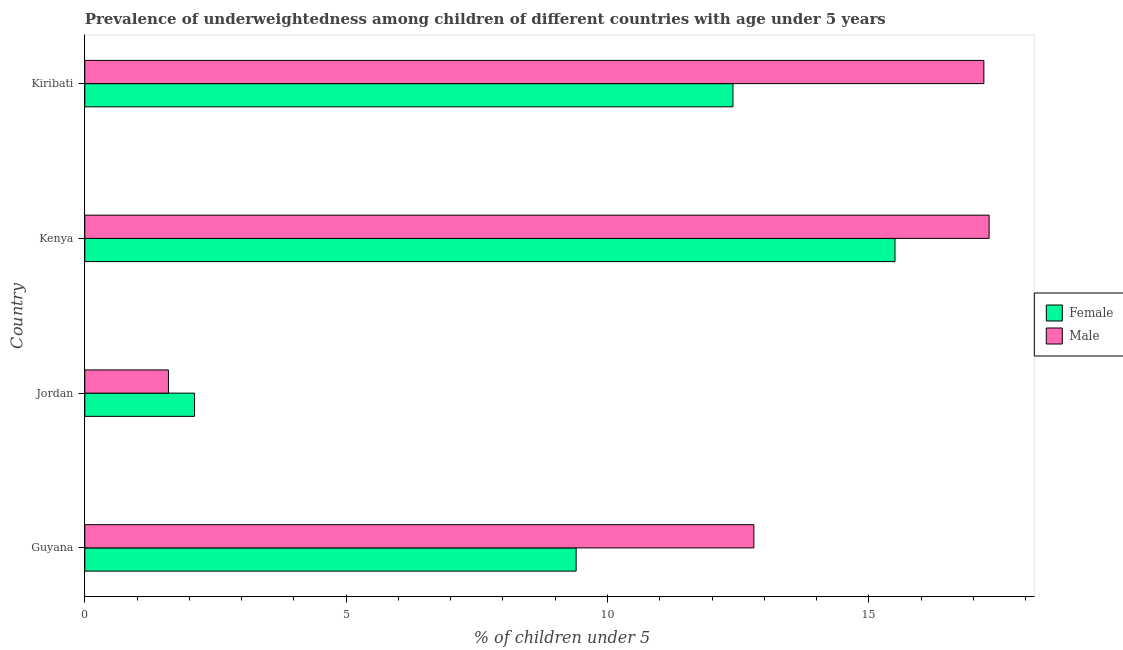How many different coloured bars are there?
Offer a terse response. 2. How many groups of bars are there?
Provide a succinct answer. 4. Are the number of bars per tick equal to the number of legend labels?
Your answer should be very brief. Yes. Are the number of bars on each tick of the Y-axis equal?
Provide a succinct answer. Yes. How many bars are there on the 4th tick from the top?
Your answer should be very brief. 2. What is the label of the 4th group of bars from the top?
Provide a short and direct response. Guyana. In how many cases, is the number of bars for a given country not equal to the number of legend labels?
Keep it short and to the point. 0. What is the percentage of underweighted female children in Guyana?
Give a very brief answer. 9.4. Across all countries, what is the maximum percentage of underweighted male children?
Offer a very short reply. 17.3. Across all countries, what is the minimum percentage of underweighted female children?
Ensure brevity in your answer.  2.1. In which country was the percentage of underweighted female children maximum?
Offer a very short reply. Kenya. In which country was the percentage of underweighted female children minimum?
Give a very brief answer. Jordan. What is the total percentage of underweighted male children in the graph?
Your answer should be compact. 48.9. What is the difference between the percentage of underweighted male children in Kenya and the percentage of underweighted female children in Kiribati?
Ensure brevity in your answer.  4.9. What is the average percentage of underweighted male children per country?
Provide a succinct answer. 12.22. In how many countries, is the percentage of underweighted female children greater than 4 %?
Ensure brevity in your answer.  3. What is the ratio of the percentage of underweighted male children in Guyana to that in Kiribati?
Keep it short and to the point. 0.74. Is the difference between the percentage of underweighted male children in Jordan and Kenya greater than the difference between the percentage of underweighted female children in Jordan and Kenya?
Your answer should be very brief. No. What is the difference between the highest and the lowest percentage of underweighted male children?
Provide a short and direct response. 15.7. In how many countries, is the percentage of underweighted male children greater than the average percentage of underweighted male children taken over all countries?
Offer a terse response. 3. What does the 1st bar from the top in Jordan represents?
Your response must be concise. Male. How many bars are there?
Provide a succinct answer. 8. Are the values on the major ticks of X-axis written in scientific E-notation?
Your answer should be compact. No. Does the graph contain any zero values?
Your answer should be compact. No. What is the title of the graph?
Offer a very short reply. Prevalence of underweightedness among children of different countries with age under 5 years. What is the label or title of the X-axis?
Keep it short and to the point.  % of children under 5. What is the label or title of the Y-axis?
Provide a succinct answer. Country. What is the  % of children under 5 of Female in Guyana?
Ensure brevity in your answer.  9.4. What is the  % of children under 5 in Male in Guyana?
Your answer should be compact. 12.8. What is the  % of children under 5 in Female in Jordan?
Your answer should be very brief. 2.1. What is the  % of children under 5 in Male in Jordan?
Provide a short and direct response. 1.6. What is the  % of children under 5 of Female in Kenya?
Give a very brief answer. 15.5. What is the  % of children under 5 of Male in Kenya?
Your answer should be compact. 17.3. What is the  % of children under 5 in Female in Kiribati?
Provide a succinct answer. 12.4. What is the  % of children under 5 in Male in Kiribati?
Offer a terse response. 17.2. Across all countries, what is the maximum  % of children under 5 of Male?
Your response must be concise. 17.3. Across all countries, what is the minimum  % of children under 5 of Female?
Your response must be concise. 2.1. Across all countries, what is the minimum  % of children under 5 in Male?
Offer a terse response. 1.6. What is the total  % of children under 5 in Female in the graph?
Your response must be concise. 39.4. What is the total  % of children under 5 of Male in the graph?
Offer a terse response. 48.9. What is the difference between the  % of children under 5 of Female in Guyana and that in Jordan?
Your answer should be compact. 7.3. What is the difference between the  % of children under 5 in Male in Guyana and that in Jordan?
Your response must be concise. 11.2. What is the difference between the  % of children under 5 of Male in Guyana and that in Kenya?
Your response must be concise. -4.5. What is the difference between the  % of children under 5 in Female in Guyana and that in Kiribati?
Your answer should be very brief. -3. What is the difference between the  % of children under 5 of Female in Jordan and that in Kenya?
Your answer should be very brief. -13.4. What is the difference between the  % of children under 5 in Male in Jordan and that in Kenya?
Your answer should be very brief. -15.7. What is the difference between the  % of children under 5 of Male in Jordan and that in Kiribati?
Provide a succinct answer. -15.6. What is the difference between the  % of children under 5 of Female in Kenya and that in Kiribati?
Make the answer very short. 3.1. What is the difference between the  % of children under 5 of Female in Guyana and the  % of children under 5 of Male in Kiribati?
Make the answer very short. -7.8. What is the difference between the  % of children under 5 in Female in Jordan and the  % of children under 5 in Male in Kenya?
Ensure brevity in your answer.  -15.2. What is the difference between the  % of children under 5 of Female in Jordan and the  % of children under 5 of Male in Kiribati?
Provide a short and direct response. -15.1. What is the average  % of children under 5 of Female per country?
Offer a terse response. 9.85. What is the average  % of children under 5 in Male per country?
Ensure brevity in your answer.  12.22. What is the difference between the  % of children under 5 in Female and  % of children under 5 in Male in Guyana?
Offer a terse response. -3.4. What is the difference between the  % of children under 5 in Female and  % of children under 5 in Male in Jordan?
Offer a terse response. 0.5. What is the ratio of the  % of children under 5 of Female in Guyana to that in Jordan?
Provide a short and direct response. 4.48. What is the ratio of the  % of children under 5 in Female in Guyana to that in Kenya?
Give a very brief answer. 0.61. What is the ratio of the  % of children under 5 in Male in Guyana to that in Kenya?
Provide a short and direct response. 0.74. What is the ratio of the  % of children under 5 of Female in Guyana to that in Kiribati?
Your answer should be compact. 0.76. What is the ratio of the  % of children under 5 in Male in Guyana to that in Kiribati?
Provide a succinct answer. 0.74. What is the ratio of the  % of children under 5 of Female in Jordan to that in Kenya?
Provide a succinct answer. 0.14. What is the ratio of the  % of children under 5 in Male in Jordan to that in Kenya?
Make the answer very short. 0.09. What is the ratio of the  % of children under 5 in Female in Jordan to that in Kiribati?
Provide a succinct answer. 0.17. What is the ratio of the  % of children under 5 of Male in Jordan to that in Kiribati?
Provide a short and direct response. 0.09. What is the ratio of the  % of children under 5 of Male in Kenya to that in Kiribati?
Keep it short and to the point. 1.01. What is the difference between the highest and the lowest  % of children under 5 in Female?
Your response must be concise. 13.4. What is the difference between the highest and the lowest  % of children under 5 of Male?
Give a very brief answer. 15.7. 